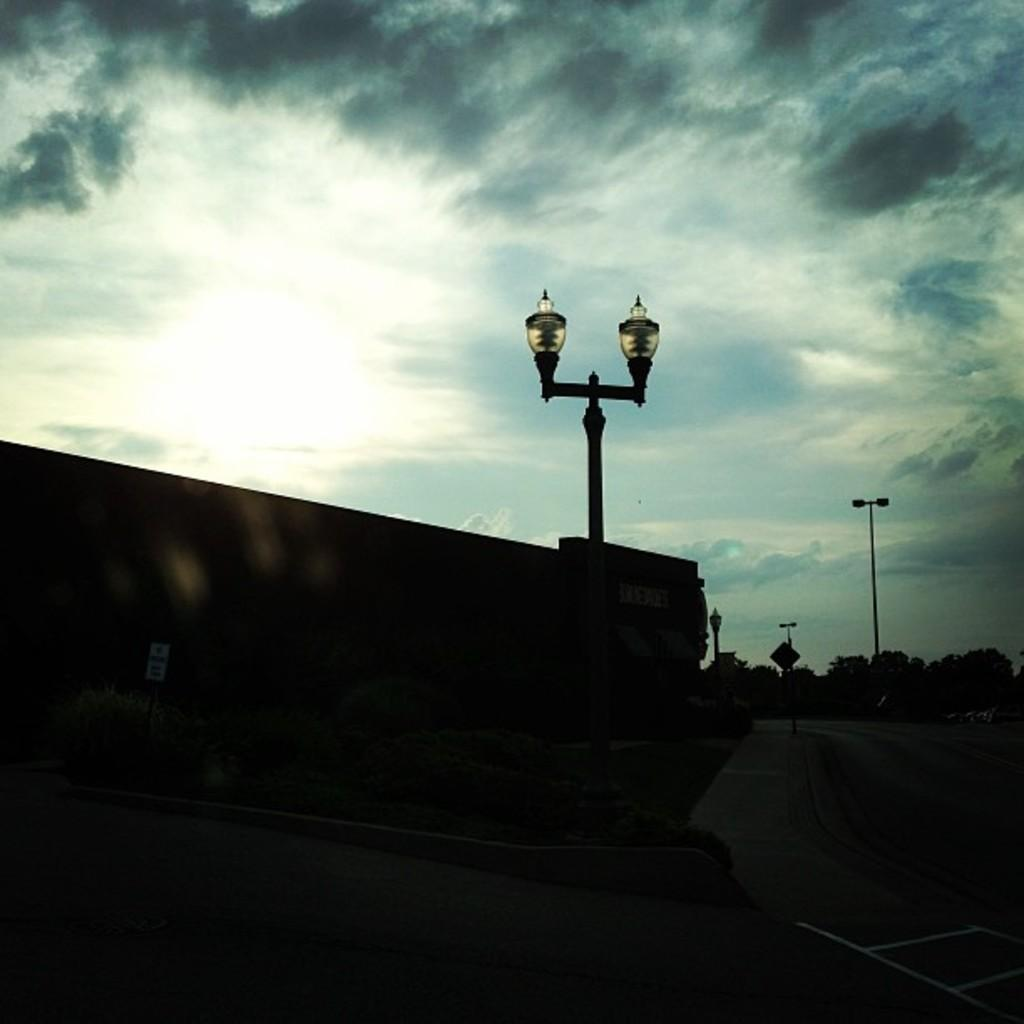What is the weather like in the image? The sky in the image is cloudy. Despite the clouds, is there any sunlight visible in the image? Yes, sunlight is visible in the image. What type of lighting fixture can be seen in the image? There is a lamp on the wall in the image. What is located on the right side of the image? There is a pole visible on the right side of the image. What type of pancake is being served in the aftermath of the storm in the image? There is no pancake or storm present in the image, so it is not possible to answer that question. 